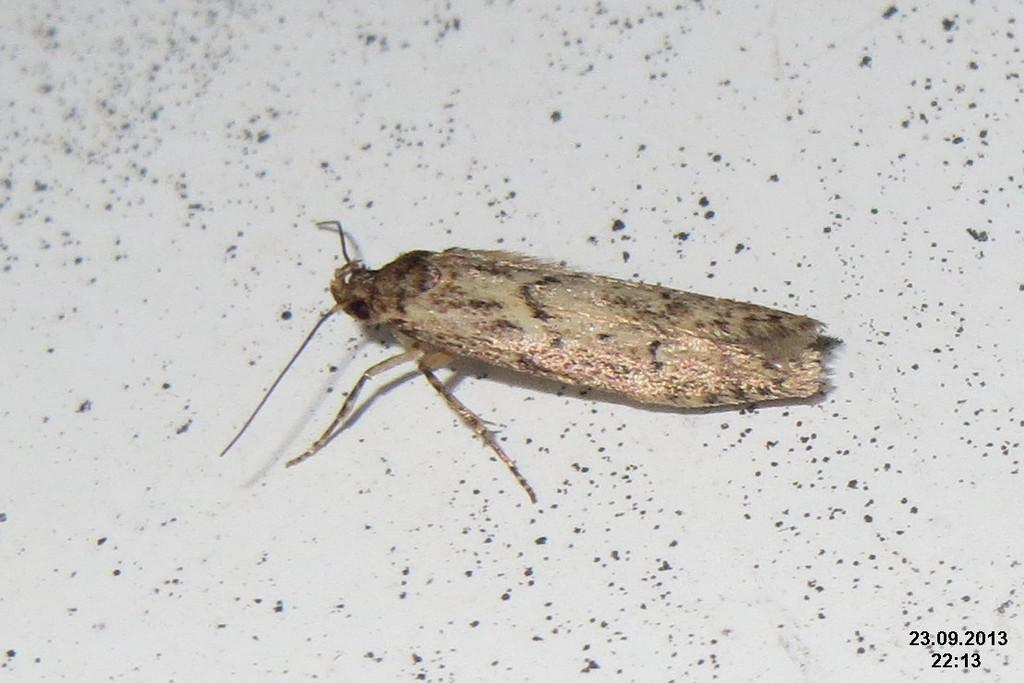What type of creature is present in the image? There is an insect in the image. Where is the insect located in the image? The insect is on a surface. What type of arch can be seen in the image? There is no arch present in the image; it features an insect on a surface. What degree does the insect have in the image? The insect does not have a degree in the image; it is simply an insect on a surface. 